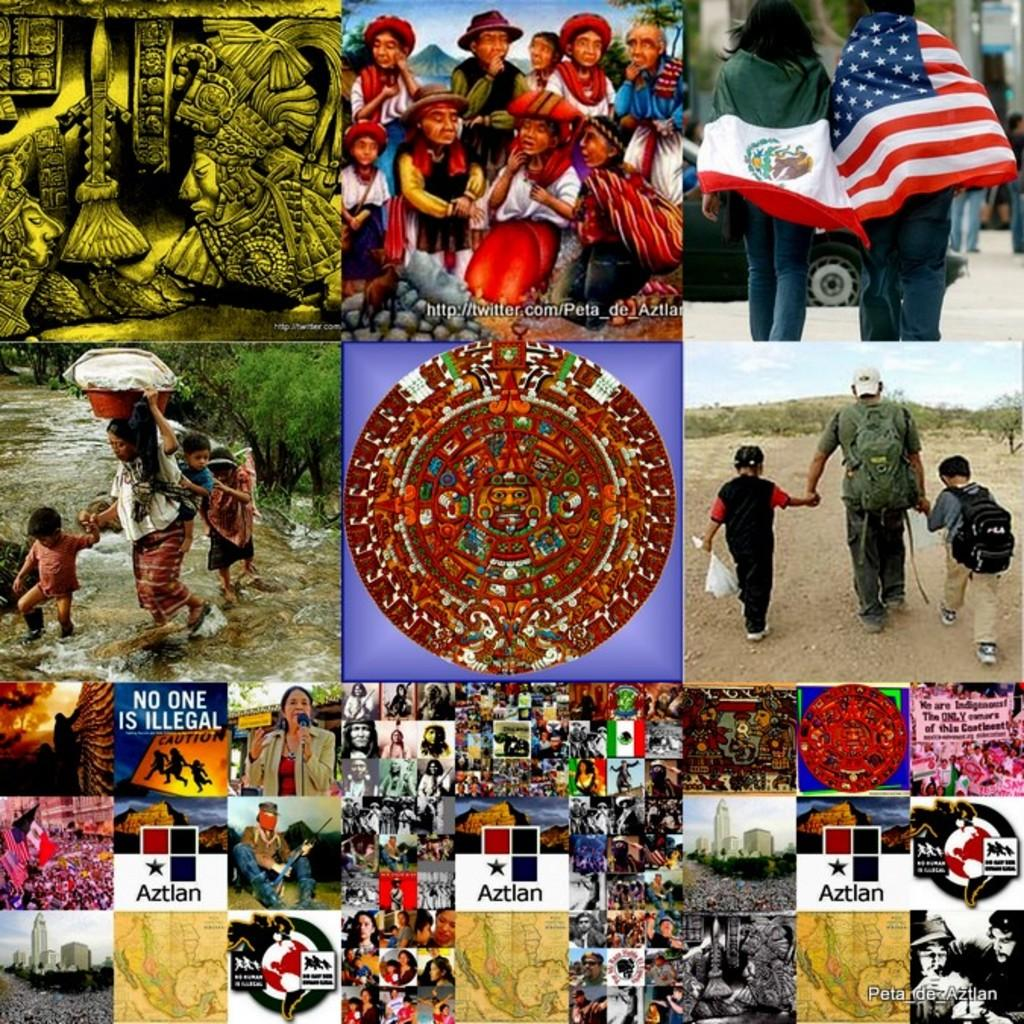What type of artwork is the image? The image is a collage. Can you describe the subjects in the image? There is a group of people, flags, buildings, maps, and sculptures in the image. What natural elements can be seen in the image? There is water and trees visible in the image. Are there any marks or stamps on the image? Yes, there are watermarks on the image. What type of whip is being used by the people in the image? There is no whip present in the image; it features a collage with various subjects and elements. How much profit can be made from the flags in the image? There is no indication of profit or commerce related to the flags in the image; they are simply part of the collage. 